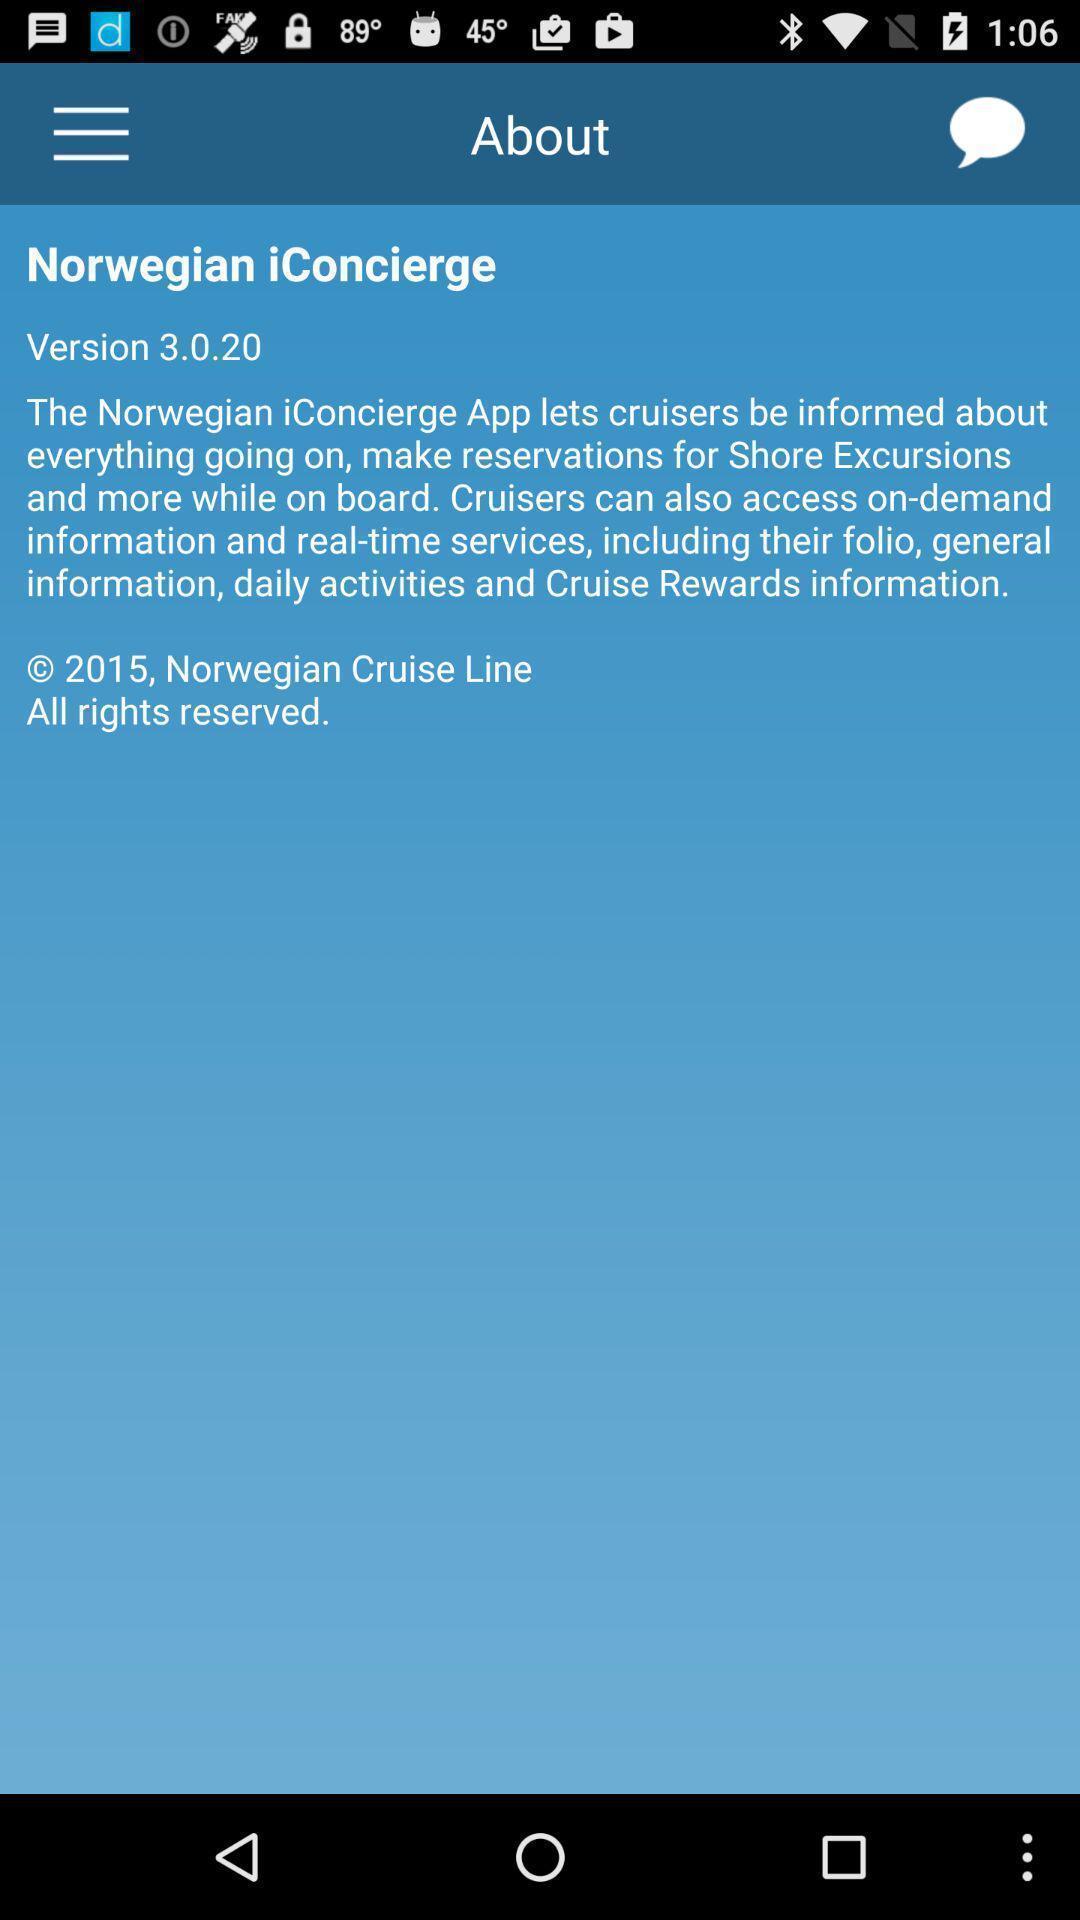Describe the visual elements of this screenshot. Page is about the information of daily activities. 